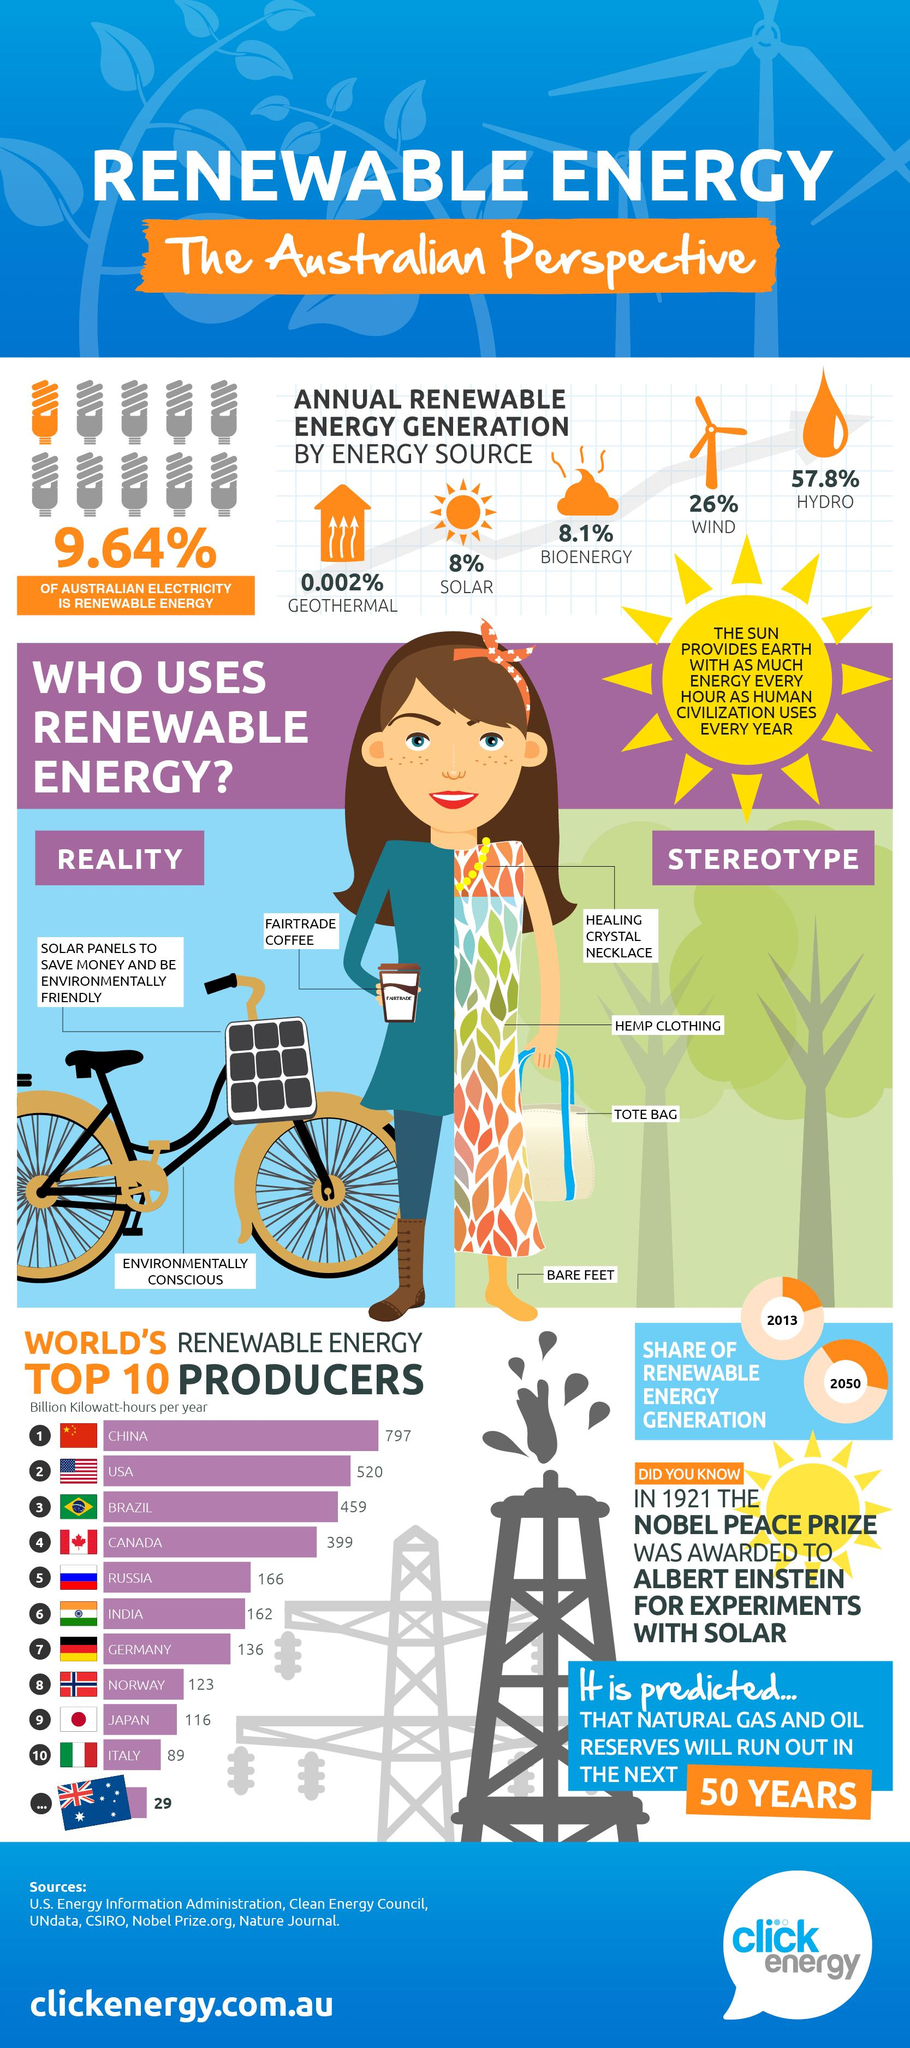Specify some key components in this picture. Hydroelectricity is the primary source of renewable energy in Australia. The United States is the world's second largest producer of renewable energy among the given countries. In the United States, approximately 520 billion kilowatt-hours of renewable energy is produced annually. According to data, 90.36% of Australian electricity is generated from non-renewable energy sources. China is the world's leading producer of renewable energy among the given countries. 